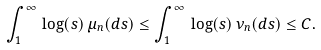<formula> <loc_0><loc_0><loc_500><loc_500>\int _ { 1 } ^ { \infty } \, \log ( s ) \, \mu _ { n } ( d s ) \leq \int _ { 1 } ^ { \infty } \, \log ( s ) \, \nu _ { n } ( d s ) \leq C .</formula> 